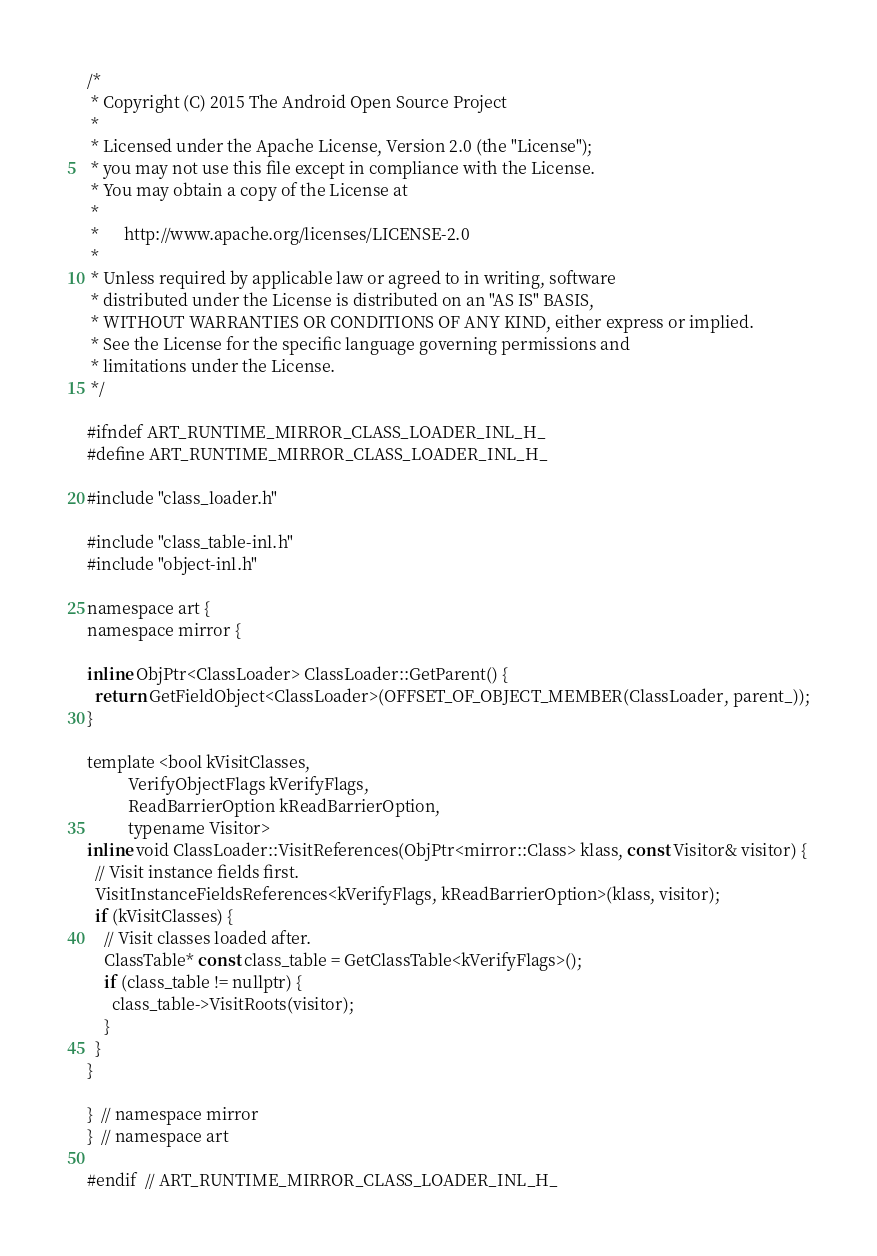Convert code to text. <code><loc_0><loc_0><loc_500><loc_500><_C_>/*
 * Copyright (C) 2015 The Android Open Source Project
 *
 * Licensed under the Apache License, Version 2.0 (the "License");
 * you may not use this file except in compliance with the License.
 * You may obtain a copy of the License at
 *
 *      http://www.apache.org/licenses/LICENSE-2.0
 *
 * Unless required by applicable law or agreed to in writing, software
 * distributed under the License is distributed on an "AS IS" BASIS,
 * WITHOUT WARRANTIES OR CONDITIONS OF ANY KIND, either express or implied.
 * See the License for the specific language governing permissions and
 * limitations under the License.
 */

#ifndef ART_RUNTIME_MIRROR_CLASS_LOADER_INL_H_
#define ART_RUNTIME_MIRROR_CLASS_LOADER_INL_H_

#include "class_loader.h"

#include "class_table-inl.h"
#include "object-inl.h"

namespace art {
namespace mirror {

inline ObjPtr<ClassLoader> ClassLoader::GetParent() {
  return GetFieldObject<ClassLoader>(OFFSET_OF_OBJECT_MEMBER(ClassLoader, parent_));
}

template <bool kVisitClasses,
          VerifyObjectFlags kVerifyFlags,
          ReadBarrierOption kReadBarrierOption,
          typename Visitor>
inline void ClassLoader::VisitReferences(ObjPtr<mirror::Class> klass, const Visitor& visitor) {
  // Visit instance fields first.
  VisitInstanceFieldsReferences<kVerifyFlags, kReadBarrierOption>(klass, visitor);
  if (kVisitClasses) {
    // Visit classes loaded after.
    ClassTable* const class_table = GetClassTable<kVerifyFlags>();
    if (class_table != nullptr) {
      class_table->VisitRoots(visitor);
    }
  }
}

}  // namespace mirror
}  // namespace art

#endif  // ART_RUNTIME_MIRROR_CLASS_LOADER_INL_H_
</code> 